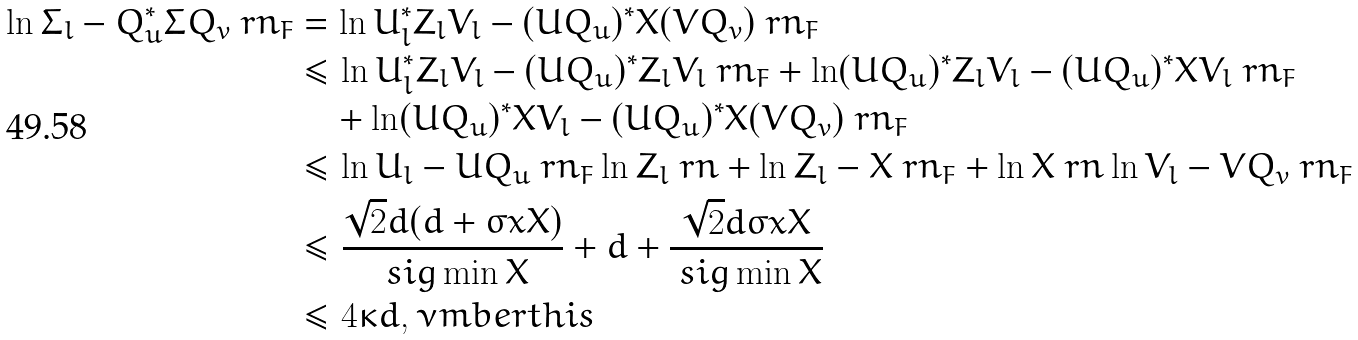<formula> <loc_0><loc_0><loc_500><loc_500>\ln \Sigma _ { l } - Q _ { u } ^ { * } \Sigma Q _ { v } \ r n _ { F } & = \ln U _ { l } ^ { * } Z _ { l } V _ { l } - ( U Q _ { u } ) ^ { * } X ( V Q _ { v } ) \ r n _ { F } \\ & \leq \ln U _ { l } ^ { * } Z _ { l } V _ { l } - ( U Q _ { u } ) ^ { * } Z _ { l } V _ { l } \ r n _ { F } + \ln ( U Q _ { u } ) ^ { * } Z _ { l } V _ { l } - ( U Q _ { u } ) ^ { * } X V _ { l } \ r n _ { F } \\ & \quad + \ln ( U Q _ { u } ) ^ { * } X V _ { l } - ( U Q _ { u } ) ^ { * } X ( V Q _ { v } ) \ r n _ { F } \\ & \leq \ln U _ { l } - U Q _ { u } \ r n _ { F } \ln Z _ { l } \ r n + \ln Z _ { l } - X \ r n _ { F } + \ln X \ r n \ln V _ { l } - V Q _ { v } \ r n _ { F } \\ & \leq \frac { \sqrt { 2 } d ( d + \sigma x { X } ) } { \ s i g \min { X } } + d + \frac { \sqrt { 2 } d \sigma x { X } } { \ s i g \min { X } } \\ & \leq 4 \kappa d , \nu m b e r t h i s</formula> 